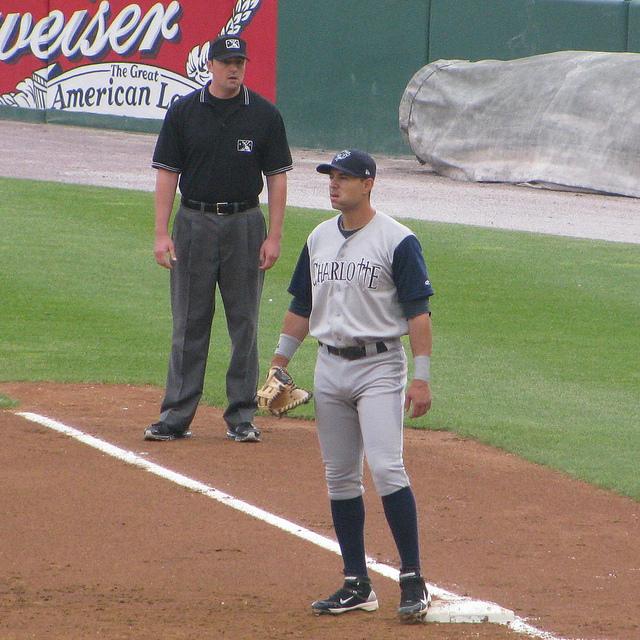Are the men wearing hats?
Quick response, please. Yes. What game is being played?
Quick response, please. Baseball. Which team is playing?
Concise answer only. Charlotte. Is this game sponsored?
Quick response, please. Yes. Would this man wear a jock strap in his regular job?
Quick response, please. Yes. 